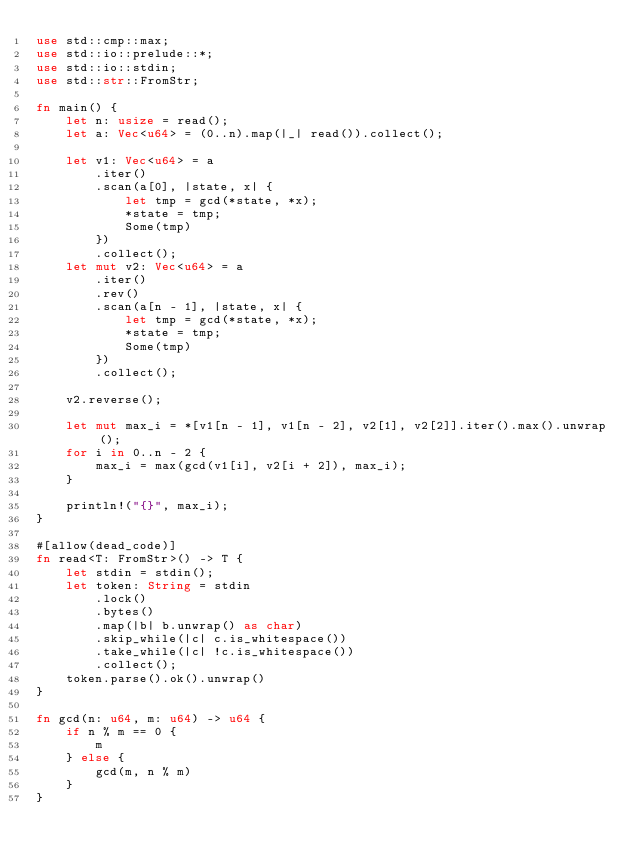Convert code to text. <code><loc_0><loc_0><loc_500><loc_500><_Rust_>use std::cmp::max;
use std::io::prelude::*;
use std::io::stdin;
use std::str::FromStr;

fn main() {
    let n: usize = read();
    let a: Vec<u64> = (0..n).map(|_| read()).collect();

    let v1: Vec<u64> = a
        .iter()
        .scan(a[0], |state, x| {
            let tmp = gcd(*state, *x);
            *state = tmp;
            Some(tmp)
        })
        .collect();
    let mut v2: Vec<u64> = a
        .iter()
        .rev()
        .scan(a[n - 1], |state, x| {
            let tmp = gcd(*state, *x);
            *state = tmp;
            Some(tmp)
        })
        .collect();

    v2.reverse();

    let mut max_i = *[v1[n - 1], v1[n - 2], v2[1], v2[2]].iter().max().unwrap();
    for i in 0..n - 2 {
        max_i = max(gcd(v1[i], v2[i + 2]), max_i);
    }

    println!("{}", max_i);
}

#[allow(dead_code)]
fn read<T: FromStr>() -> T {
    let stdin = stdin();
    let token: String = stdin
        .lock()
        .bytes()
        .map(|b| b.unwrap() as char)
        .skip_while(|c| c.is_whitespace())
        .take_while(|c| !c.is_whitespace())
        .collect();
    token.parse().ok().unwrap()
}

fn gcd(n: u64, m: u64) -> u64 {
    if n % m == 0 {
        m
    } else {
        gcd(m, n % m)
    }
}
</code> 